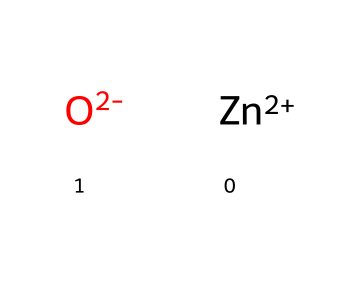What is the charge of the zinc ion in this compound? The SMILES representation [Zn+2] indicates that the zinc ion has a 2+ charge. The positive sign (+) denotes the charge, and the number 2 indicates the magnitude.
Answer: 2+ How many atoms are present in total in this molecular composition? The SMILES notation consists of two parts: one zinc atom (Zn) and one oxygen atom (O), totaling two atoms present in the structural representation.
Answer: 2 What type of bond is formed between zinc and oxygen in zinc oxide? Zinc oxide (ZnO) typically involves ionic bonding, as indicated by the charges in the structure. In this case, the division of formal charges suggests that there is a charge transfer leading to ionic character.
Answer: ionic What is the oxidation state of zinc in this compound? This compound shows zinc with a charge of +2, indicating that the oxidation state of zinc is +2 in the coordination compound.
Answer: +2 Which type of compound does zinc oxide represent in the context of coordination compounds? Zinc oxide falls under the category of coordination compounds since it consists of a central metal ion (Zn+2) coordinated with oxide ions, representing a simple metal oxide.
Answer: coordination compound Why is zinc oxide commonly used in anti-chafing creams? Zinc oxide is used in anti-chafing creams due to its soothing properties and effectiveness as a barrier against moisture, which can prevent skin irritation during physical activity. This characteristic is linked to its chemical properties.
Answer: soothing properties 